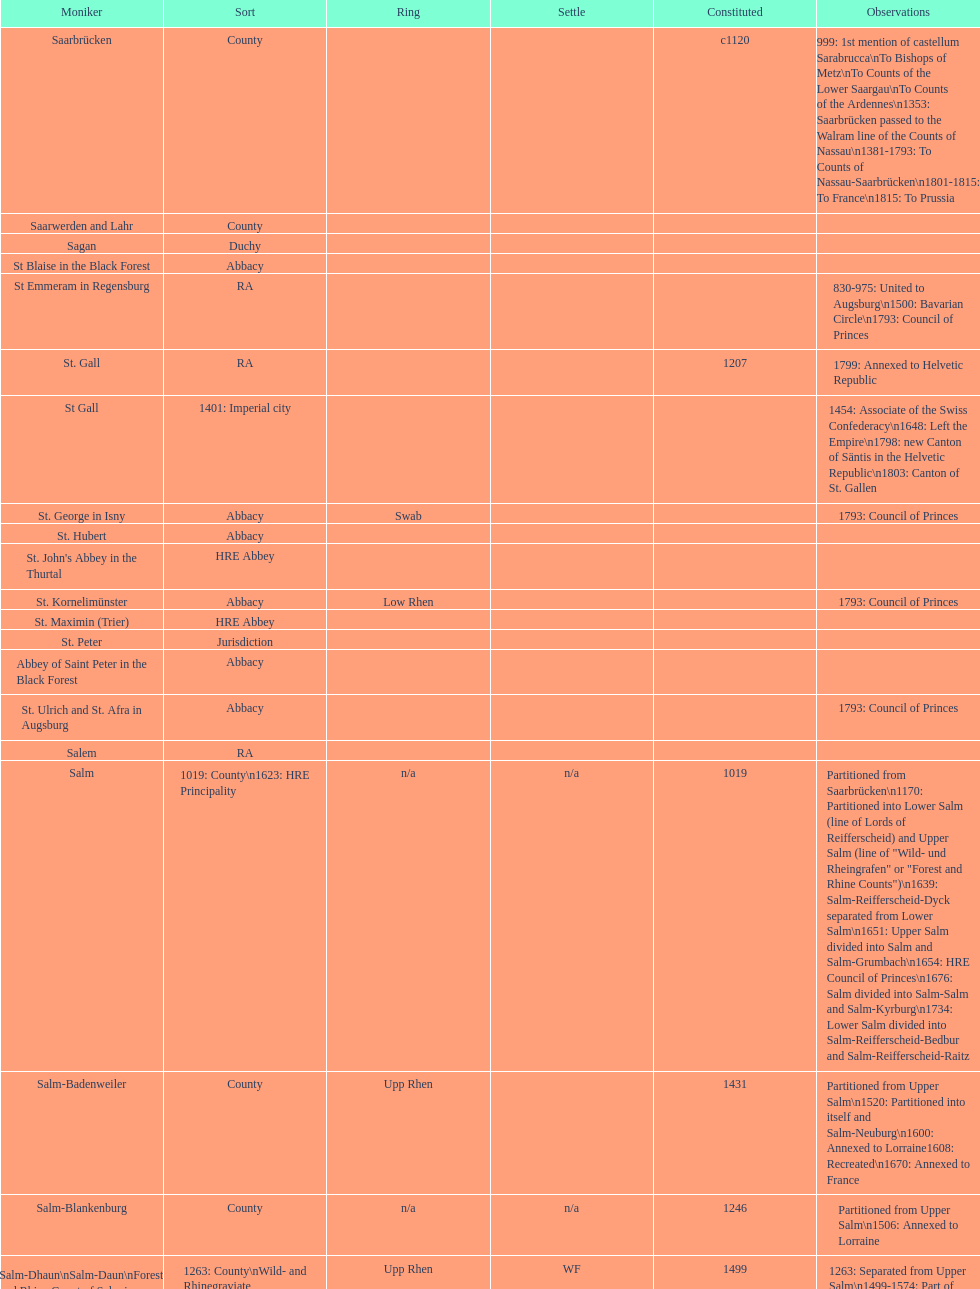What is the state above "sagan"? Saarwerden and Lahr. 